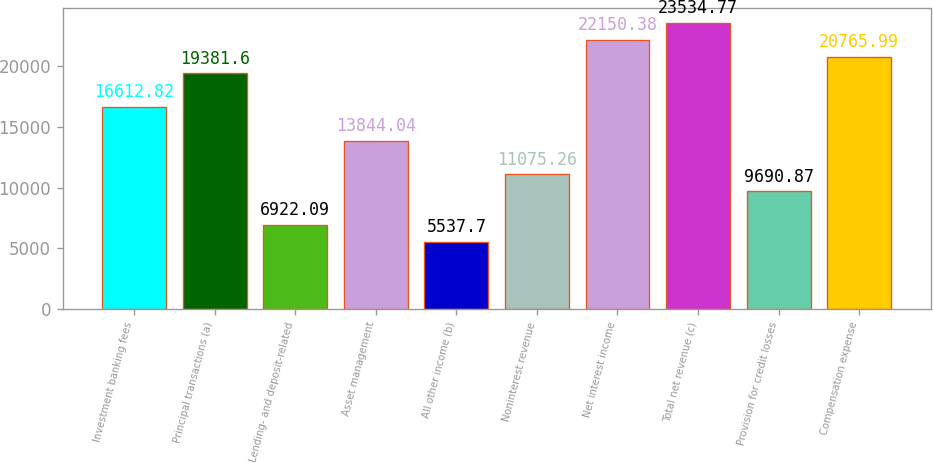<chart> <loc_0><loc_0><loc_500><loc_500><bar_chart><fcel>Investment banking fees<fcel>Principal transactions (a)<fcel>Lending- and deposit-related<fcel>Asset management<fcel>All other income (b)<fcel>Noninterest revenue<fcel>Net interest income<fcel>Total net revenue (c)<fcel>Provision for credit losses<fcel>Compensation expense<nl><fcel>16612.8<fcel>19381.6<fcel>6922.09<fcel>13844<fcel>5537.7<fcel>11075.3<fcel>22150.4<fcel>23534.8<fcel>9690.87<fcel>20766<nl></chart> 